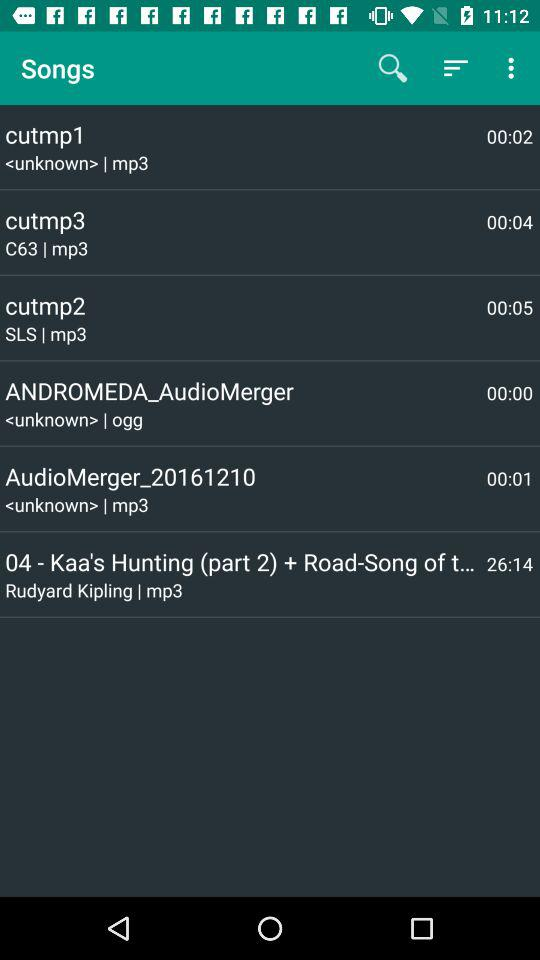What song has a duration of 00:05? The song is "cutmp2". 